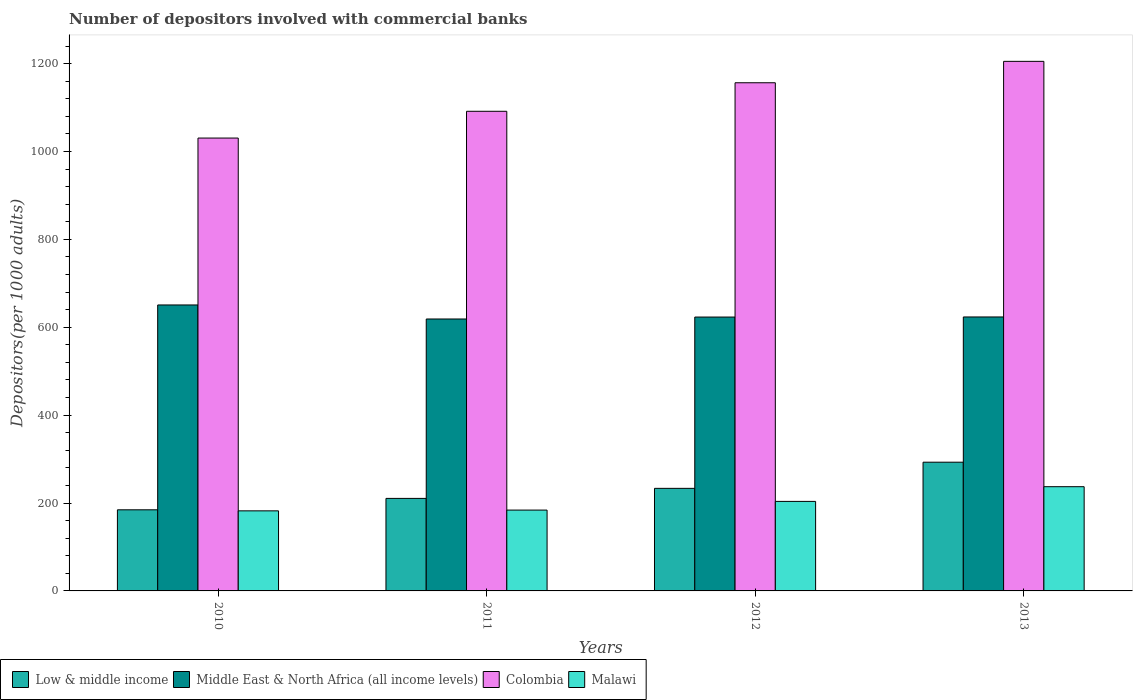How many different coloured bars are there?
Your answer should be compact. 4. How many groups of bars are there?
Provide a short and direct response. 4. What is the label of the 3rd group of bars from the left?
Your answer should be compact. 2012. In how many cases, is the number of bars for a given year not equal to the number of legend labels?
Provide a short and direct response. 0. What is the number of depositors involved with commercial banks in Low & middle income in 2012?
Provide a short and direct response. 233.41. Across all years, what is the maximum number of depositors involved with commercial banks in Low & middle income?
Offer a very short reply. 292.93. Across all years, what is the minimum number of depositors involved with commercial banks in Malawi?
Your answer should be compact. 182.23. In which year was the number of depositors involved with commercial banks in Middle East & North Africa (all income levels) minimum?
Offer a terse response. 2011. What is the total number of depositors involved with commercial banks in Malawi in the graph?
Offer a very short reply. 807.1. What is the difference between the number of depositors involved with commercial banks in Low & middle income in 2011 and that in 2013?
Offer a very short reply. -82.37. What is the difference between the number of depositors involved with commercial banks in Middle East & North Africa (all income levels) in 2010 and the number of depositors involved with commercial banks in Malawi in 2013?
Your answer should be very brief. 413.58. What is the average number of depositors involved with commercial banks in Malawi per year?
Offer a terse response. 201.78. In the year 2013, what is the difference between the number of depositors involved with commercial banks in Low & middle income and number of depositors involved with commercial banks in Malawi?
Your response must be concise. 55.74. What is the ratio of the number of depositors involved with commercial banks in Colombia in 2010 to that in 2011?
Give a very brief answer. 0.94. What is the difference between the highest and the second highest number of depositors involved with commercial banks in Malawi?
Keep it short and to the point. 33.47. What is the difference between the highest and the lowest number of depositors involved with commercial banks in Malawi?
Offer a terse response. 54.96. Is it the case that in every year, the sum of the number of depositors involved with commercial banks in Malawi and number of depositors involved with commercial banks in Low & middle income is greater than the sum of number of depositors involved with commercial banks in Middle East & North Africa (all income levels) and number of depositors involved with commercial banks in Colombia?
Ensure brevity in your answer.  No. What does the 4th bar from the left in 2010 represents?
Offer a very short reply. Malawi. What does the 3rd bar from the right in 2011 represents?
Provide a short and direct response. Middle East & North Africa (all income levels). Is it the case that in every year, the sum of the number of depositors involved with commercial banks in Low & middle income and number of depositors involved with commercial banks in Colombia is greater than the number of depositors involved with commercial banks in Malawi?
Ensure brevity in your answer.  Yes. How many bars are there?
Your response must be concise. 16. Are all the bars in the graph horizontal?
Keep it short and to the point. No. What is the difference between two consecutive major ticks on the Y-axis?
Your response must be concise. 200. Are the values on the major ticks of Y-axis written in scientific E-notation?
Offer a terse response. No. Does the graph contain grids?
Offer a very short reply. No. What is the title of the graph?
Ensure brevity in your answer.  Number of depositors involved with commercial banks. Does "Burundi" appear as one of the legend labels in the graph?
Offer a very short reply. No. What is the label or title of the Y-axis?
Make the answer very short. Depositors(per 1000 adults). What is the Depositors(per 1000 adults) of Low & middle income in 2010?
Offer a terse response. 184.58. What is the Depositors(per 1000 adults) in Middle East & North Africa (all income levels) in 2010?
Ensure brevity in your answer.  650.77. What is the Depositors(per 1000 adults) of Colombia in 2010?
Provide a succinct answer. 1030.59. What is the Depositors(per 1000 adults) of Malawi in 2010?
Offer a very short reply. 182.23. What is the Depositors(per 1000 adults) of Low & middle income in 2011?
Your answer should be compact. 210.56. What is the Depositors(per 1000 adults) of Middle East & North Africa (all income levels) in 2011?
Ensure brevity in your answer.  618.84. What is the Depositors(per 1000 adults) in Colombia in 2011?
Ensure brevity in your answer.  1091.5. What is the Depositors(per 1000 adults) in Malawi in 2011?
Provide a succinct answer. 183.96. What is the Depositors(per 1000 adults) in Low & middle income in 2012?
Give a very brief answer. 233.41. What is the Depositors(per 1000 adults) of Middle East & North Africa (all income levels) in 2012?
Keep it short and to the point. 623.22. What is the Depositors(per 1000 adults) of Colombia in 2012?
Your answer should be compact. 1156.43. What is the Depositors(per 1000 adults) in Malawi in 2012?
Give a very brief answer. 203.72. What is the Depositors(per 1000 adults) in Low & middle income in 2013?
Offer a very short reply. 292.93. What is the Depositors(per 1000 adults) of Middle East & North Africa (all income levels) in 2013?
Keep it short and to the point. 623.45. What is the Depositors(per 1000 adults) of Colombia in 2013?
Offer a terse response. 1205.13. What is the Depositors(per 1000 adults) of Malawi in 2013?
Provide a succinct answer. 237.19. Across all years, what is the maximum Depositors(per 1000 adults) in Low & middle income?
Your response must be concise. 292.93. Across all years, what is the maximum Depositors(per 1000 adults) of Middle East & North Africa (all income levels)?
Provide a succinct answer. 650.77. Across all years, what is the maximum Depositors(per 1000 adults) in Colombia?
Your answer should be compact. 1205.13. Across all years, what is the maximum Depositors(per 1000 adults) in Malawi?
Offer a terse response. 237.19. Across all years, what is the minimum Depositors(per 1000 adults) in Low & middle income?
Provide a short and direct response. 184.58. Across all years, what is the minimum Depositors(per 1000 adults) of Middle East & North Africa (all income levels)?
Offer a terse response. 618.84. Across all years, what is the minimum Depositors(per 1000 adults) in Colombia?
Your answer should be compact. 1030.59. Across all years, what is the minimum Depositors(per 1000 adults) in Malawi?
Provide a succinct answer. 182.23. What is the total Depositors(per 1000 adults) in Low & middle income in the graph?
Provide a short and direct response. 921.48. What is the total Depositors(per 1000 adults) in Middle East & North Africa (all income levels) in the graph?
Your answer should be very brief. 2516.28. What is the total Depositors(per 1000 adults) in Colombia in the graph?
Your response must be concise. 4483.65. What is the total Depositors(per 1000 adults) in Malawi in the graph?
Give a very brief answer. 807.1. What is the difference between the Depositors(per 1000 adults) of Low & middle income in 2010 and that in 2011?
Your answer should be compact. -25.98. What is the difference between the Depositors(per 1000 adults) in Middle East & North Africa (all income levels) in 2010 and that in 2011?
Your answer should be very brief. 31.92. What is the difference between the Depositors(per 1000 adults) in Colombia in 2010 and that in 2011?
Provide a short and direct response. -60.9. What is the difference between the Depositors(per 1000 adults) in Malawi in 2010 and that in 2011?
Your answer should be compact. -1.73. What is the difference between the Depositors(per 1000 adults) of Low & middle income in 2010 and that in 2012?
Keep it short and to the point. -48.83. What is the difference between the Depositors(per 1000 adults) in Middle East & North Africa (all income levels) in 2010 and that in 2012?
Give a very brief answer. 27.55. What is the difference between the Depositors(per 1000 adults) of Colombia in 2010 and that in 2012?
Offer a terse response. -125.84. What is the difference between the Depositors(per 1000 adults) of Malawi in 2010 and that in 2012?
Your answer should be very brief. -21.49. What is the difference between the Depositors(per 1000 adults) of Low & middle income in 2010 and that in 2013?
Your answer should be very brief. -108.35. What is the difference between the Depositors(per 1000 adults) in Middle East & North Africa (all income levels) in 2010 and that in 2013?
Give a very brief answer. 27.32. What is the difference between the Depositors(per 1000 adults) in Colombia in 2010 and that in 2013?
Keep it short and to the point. -174.54. What is the difference between the Depositors(per 1000 adults) of Malawi in 2010 and that in 2013?
Keep it short and to the point. -54.96. What is the difference between the Depositors(per 1000 adults) in Low & middle income in 2011 and that in 2012?
Provide a short and direct response. -22.85. What is the difference between the Depositors(per 1000 adults) of Middle East & North Africa (all income levels) in 2011 and that in 2012?
Keep it short and to the point. -4.38. What is the difference between the Depositors(per 1000 adults) of Colombia in 2011 and that in 2012?
Offer a very short reply. -64.94. What is the difference between the Depositors(per 1000 adults) of Malawi in 2011 and that in 2012?
Offer a very short reply. -19.76. What is the difference between the Depositors(per 1000 adults) of Low & middle income in 2011 and that in 2013?
Your answer should be compact. -82.37. What is the difference between the Depositors(per 1000 adults) in Middle East & North Africa (all income levels) in 2011 and that in 2013?
Provide a succinct answer. -4.61. What is the difference between the Depositors(per 1000 adults) in Colombia in 2011 and that in 2013?
Keep it short and to the point. -113.64. What is the difference between the Depositors(per 1000 adults) in Malawi in 2011 and that in 2013?
Give a very brief answer. -53.23. What is the difference between the Depositors(per 1000 adults) in Low & middle income in 2012 and that in 2013?
Provide a short and direct response. -59.52. What is the difference between the Depositors(per 1000 adults) of Middle East & North Africa (all income levels) in 2012 and that in 2013?
Keep it short and to the point. -0.23. What is the difference between the Depositors(per 1000 adults) in Colombia in 2012 and that in 2013?
Ensure brevity in your answer.  -48.7. What is the difference between the Depositors(per 1000 adults) in Malawi in 2012 and that in 2013?
Offer a very short reply. -33.47. What is the difference between the Depositors(per 1000 adults) of Low & middle income in 2010 and the Depositors(per 1000 adults) of Middle East & North Africa (all income levels) in 2011?
Give a very brief answer. -434.26. What is the difference between the Depositors(per 1000 adults) of Low & middle income in 2010 and the Depositors(per 1000 adults) of Colombia in 2011?
Offer a terse response. -906.92. What is the difference between the Depositors(per 1000 adults) in Low & middle income in 2010 and the Depositors(per 1000 adults) in Malawi in 2011?
Provide a succinct answer. 0.62. What is the difference between the Depositors(per 1000 adults) in Middle East & North Africa (all income levels) in 2010 and the Depositors(per 1000 adults) in Colombia in 2011?
Your answer should be very brief. -440.73. What is the difference between the Depositors(per 1000 adults) in Middle East & North Africa (all income levels) in 2010 and the Depositors(per 1000 adults) in Malawi in 2011?
Give a very brief answer. 466.81. What is the difference between the Depositors(per 1000 adults) of Colombia in 2010 and the Depositors(per 1000 adults) of Malawi in 2011?
Your answer should be very brief. 846.63. What is the difference between the Depositors(per 1000 adults) in Low & middle income in 2010 and the Depositors(per 1000 adults) in Middle East & North Africa (all income levels) in 2012?
Make the answer very short. -438.64. What is the difference between the Depositors(per 1000 adults) in Low & middle income in 2010 and the Depositors(per 1000 adults) in Colombia in 2012?
Your answer should be very brief. -971.85. What is the difference between the Depositors(per 1000 adults) in Low & middle income in 2010 and the Depositors(per 1000 adults) in Malawi in 2012?
Your response must be concise. -19.14. What is the difference between the Depositors(per 1000 adults) of Middle East & North Africa (all income levels) in 2010 and the Depositors(per 1000 adults) of Colombia in 2012?
Your response must be concise. -505.67. What is the difference between the Depositors(per 1000 adults) in Middle East & North Africa (all income levels) in 2010 and the Depositors(per 1000 adults) in Malawi in 2012?
Your response must be concise. 447.04. What is the difference between the Depositors(per 1000 adults) of Colombia in 2010 and the Depositors(per 1000 adults) of Malawi in 2012?
Your response must be concise. 826.87. What is the difference between the Depositors(per 1000 adults) in Low & middle income in 2010 and the Depositors(per 1000 adults) in Middle East & North Africa (all income levels) in 2013?
Provide a succinct answer. -438.87. What is the difference between the Depositors(per 1000 adults) in Low & middle income in 2010 and the Depositors(per 1000 adults) in Colombia in 2013?
Ensure brevity in your answer.  -1020.55. What is the difference between the Depositors(per 1000 adults) of Low & middle income in 2010 and the Depositors(per 1000 adults) of Malawi in 2013?
Provide a short and direct response. -52.61. What is the difference between the Depositors(per 1000 adults) in Middle East & North Africa (all income levels) in 2010 and the Depositors(per 1000 adults) in Colombia in 2013?
Your answer should be very brief. -554.37. What is the difference between the Depositors(per 1000 adults) of Middle East & North Africa (all income levels) in 2010 and the Depositors(per 1000 adults) of Malawi in 2013?
Your response must be concise. 413.58. What is the difference between the Depositors(per 1000 adults) of Colombia in 2010 and the Depositors(per 1000 adults) of Malawi in 2013?
Make the answer very short. 793.4. What is the difference between the Depositors(per 1000 adults) of Low & middle income in 2011 and the Depositors(per 1000 adults) of Middle East & North Africa (all income levels) in 2012?
Offer a very short reply. -412.66. What is the difference between the Depositors(per 1000 adults) in Low & middle income in 2011 and the Depositors(per 1000 adults) in Colombia in 2012?
Ensure brevity in your answer.  -945.87. What is the difference between the Depositors(per 1000 adults) in Low & middle income in 2011 and the Depositors(per 1000 adults) in Malawi in 2012?
Your answer should be very brief. 6.84. What is the difference between the Depositors(per 1000 adults) of Middle East & North Africa (all income levels) in 2011 and the Depositors(per 1000 adults) of Colombia in 2012?
Your answer should be very brief. -537.59. What is the difference between the Depositors(per 1000 adults) of Middle East & North Africa (all income levels) in 2011 and the Depositors(per 1000 adults) of Malawi in 2012?
Offer a terse response. 415.12. What is the difference between the Depositors(per 1000 adults) in Colombia in 2011 and the Depositors(per 1000 adults) in Malawi in 2012?
Your response must be concise. 887.77. What is the difference between the Depositors(per 1000 adults) of Low & middle income in 2011 and the Depositors(per 1000 adults) of Middle East & North Africa (all income levels) in 2013?
Ensure brevity in your answer.  -412.89. What is the difference between the Depositors(per 1000 adults) in Low & middle income in 2011 and the Depositors(per 1000 adults) in Colombia in 2013?
Offer a terse response. -994.57. What is the difference between the Depositors(per 1000 adults) in Low & middle income in 2011 and the Depositors(per 1000 adults) in Malawi in 2013?
Provide a short and direct response. -26.63. What is the difference between the Depositors(per 1000 adults) of Middle East & North Africa (all income levels) in 2011 and the Depositors(per 1000 adults) of Colombia in 2013?
Keep it short and to the point. -586.29. What is the difference between the Depositors(per 1000 adults) of Middle East & North Africa (all income levels) in 2011 and the Depositors(per 1000 adults) of Malawi in 2013?
Provide a succinct answer. 381.65. What is the difference between the Depositors(per 1000 adults) of Colombia in 2011 and the Depositors(per 1000 adults) of Malawi in 2013?
Your answer should be very brief. 854.31. What is the difference between the Depositors(per 1000 adults) of Low & middle income in 2012 and the Depositors(per 1000 adults) of Middle East & North Africa (all income levels) in 2013?
Offer a very short reply. -390.04. What is the difference between the Depositors(per 1000 adults) of Low & middle income in 2012 and the Depositors(per 1000 adults) of Colombia in 2013?
Offer a very short reply. -971.73. What is the difference between the Depositors(per 1000 adults) of Low & middle income in 2012 and the Depositors(per 1000 adults) of Malawi in 2013?
Give a very brief answer. -3.78. What is the difference between the Depositors(per 1000 adults) in Middle East & North Africa (all income levels) in 2012 and the Depositors(per 1000 adults) in Colombia in 2013?
Ensure brevity in your answer.  -581.91. What is the difference between the Depositors(per 1000 adults) in Middle East & North Africa (all income levels) in 2012 and the Depositors(per 1000 adults) in Malawi in 2013?
Provide a succinct answer. 386.03. What is the difference between the Depositors(per 1000 adults) in Colombia in 2012 and the Depositors(per 1000 adults) in Malawi in 2013?
Your answer should be very brief. 919.24. What is the average Depositors(per 1000 adults) in Low & middle income per year?
Offer a terse response. 230.37. What is the average Depositors(per 1000 adults) in Middle East & North Africa (all income levels) per year?
Ensure brevity in your answer.  629.07. What is the average Depositors(per 1000 adults) of Colombia per year?
Keep it short and to the point. 1120.91. What is the average Depositors(per 1000 adults) in Malawi per year?
Make the answer very short. 201.78. In the year 2010, what is the difference between the Depositors(per 1000 adults) in Low & middle income and Depositors(per 1000 adults) in Middle East & North Africa (all income levels)?
Your answer should be compact. -466.19. In the year 2010, what is the difference between the Depositors(per 1000 adults) of Low & middle income and Depositors(per 1000 adults) of Colombia?
Provide a short and direct response. -846.01. In the year 2010, what is the difference between the Depositors(per 1000 adults) in Low & middle income and Depositors(per 1000 adults) in Malawi?
Offer a terse response. 2.35. In the year 2010, what is the difference between the Depositors(per 1000 adults) of Middle East & North Africa (all income levels) and Depositors(per 1000 adults) of Colombia?
Provide a succinct answer. -379.82. In the year 2010, what is the difference between the Depositors(per 1000 adults) in Middle East & North Africa (all income levels) and Depositors(per 1000 adults) in Malawi?
Provide a succinct answer. 468.54. In the year 2010, what is the difference between the Depositors(per 1000 adults) of Colombia and Depositors(per 1000 adults) of Malawi?
Make the answer very short. 848.36. In the year 2011, what is the difference between the Depositors(per 1000 adults) of Low & middle income and Depositors(per 1000 adults) of Middle East & North Africa (all income levels)?
Provide a succinct answer. -408.28. In the year 2011, what is the difference between the Depositors(per 1000 adults) of Low & middle income and Depositors(per 1000 adults) of Colombia?
Provide a succinct answer. -880.93. In the year 2011, what is the difference between the Depositors(per 1000 adults) in Low & middle income and Depositors(per 1000 adults) in Malawi?
Your response must be concise. 26.6. In the year 2011, what is the difference between the Depositors(per 1000 adults) in Middle East & North Africa (all income levels) and Depositors(per 1000 adults) in Colombia?
Make the answer very short. -472.65. In the year 2011, what is the difference between the Depositors(per 1000 adults) in Middle East & North Africa (all income levels) and Depositors(per 1000 adults) in Malawi?
Keep it short and to the point. 434.88. In the year 2011, what is the difference between the Depositors(per 1000 adults) of Colombia and Depositors(per 1000 adults) of Malawi?
Give a very brief answer. 907.54. In the year 2012, what is the difference between the Depositors(per 1000 adults) of Low & middle income and Depositors(per 1000 adults) of Middle East & North Africa (all income levels)?
Provide a short and direct response. -389.81. In the year 2012, what is the difference between the Depositors(per 1000 adults) of Low & middle income and Depositors(per 1000 adults) of Colombia?
Offer a terse response. -923.03. In the year 2012, what is the difference between the Depositors(per 1000 adults) in Low & middle income and Depositors(per 1000 adults) in Malawi?
Ensure brevity in your answer.  29.68. In the year 2012, what is the difference between the Depositors(per 1000 adults) in Middle East & North Africa (all income levels) and Depositors(per 1000 adults) in Colombia?
Provide a short and direct response. -533.21. In the year 2012, what is the difference between the Depositors(per 1000 adults) of Middle East & North Africa (all income levels) and Depositors(per 1000 adults) of Malawi?
Give a very brief answer. 419.5. In the year 2012, what is the difference between the Depositors(per 1000 adults) of Colombia and Depositors(per 1000 adults) of Malawi?
Offer a terse response. 952.71. In the year 2013, what is the difference between the Depositors(per 1000 adults) of Low & middle income and Depositors(per 1000 adults) of Middle East & North Africa (all income levels)?
Keep it short and to the point. -330.52. In the year 2013, what is the difference between the Depositors(per 1000 adults) in Low & middle income and Depositors(per 1000 adults) in Colombia?
Offer a terse response. -912.2. In the year 2013, what is the difference between the Depositors(per 1000 adults) in Low & middle income and Depositors(per 1000 adults) in Malawi?
Keep it short and to the point. 55.74. In the year 2013, what is the difference between the Depositors(per 1000 adults) in Middle East & North Africa (all income levels) and Depositors(per 1000 adults) in Colombia?
Provide a succinct answer. -581.69. In the year 2013, what is the difference between the Depositors(per 1000 adults) in Middle East & North Africa (all income levels) and Depositors(per 1000 adults) in Malawi?
Your answer should be compact. 386.26. In the year 2013, what is the difference between the Depositors(per 1000 adults) of Colombia and Depositors(per 1000 adults) of Malawi?
Your answer should be very brief. 967.94. What is the ratio of the Depositors(per 1000 adults) of Low & middle income in 2010 to that in 2011?
Your response must be concise. 0.88. What is the ratio of the Depositors(per 1000 adults) of Middle East & North Africa (all income levels) in 2010 to that in 2011?
Make the answer very short. 1.05. What is the ratio of the Depositors(per 1000 adults) of Colombia in 2010 to that in 2011?
Give a very brief answer. 0.94. What is the ratio of the Depositors(per 1000 adults) in Malawi in 2010 to that in 2011?
Offer a very short reply. 0.99. What is the ratio of the Depositors(per 1000 adults) of Low & middle income in 2010 to that in 2012?
Your response must be concise. 0.79. What is the ratio of the Depositors(per 1000 adults) in Middle East & North Africa (all income levels) in 2010 to that in 2012?
Your answer should be compact. 1.04. What is the ratio of the Depositors(per 1000 adults) of Colombia in 2010 to that in 2012?
Keep it short and to the point. 0.89. What is the ratio of the Depositors(per 1000 adults) of Malawi in 2010 to that in 2012?
Offer a terse response. 0.89. What is the ratio of the Depositors(per 1000 adults) in Low & middle income in 2010 to that in 2013?
Ensure brevity in your answer.  0.63. What is the ratio of the Depositors(per 1000 adults) of Middle East & North Africa (all income levels) in 2010 to that in 2013?
Ensure brevity in your answer.  1.04. What is the ratio of the Depositors(per 1000 adults) of Colombia in 2010 to that in 2013?
Offer a terse response. 0.86. What is the ratio of the Depositors(per 1000 adults) of Malawi in 2010 to that in 2013?
Offer a very short reply. 0.77. What is the ratio of the Depositors(per 1000 adults) in Low & middle income in 2011 to that in 2012?
Ensure brevity in your answer.  0.9. What is the ratio of the Depositors(per 1000 adults) in Colombia in 2011 to that in 2012?
Offer a very short reply. 0.94. What is the ratio of the Depositors(per 1000 adults) in Malawi in 2011 to that in 2012?
Ensure brevity in your answer.  0.9. What is the ratio of the Depositors(per 1000 adults) of Low & middle income in 2011 to that in 2013?
Make the answer very short. 0.72. What is the ratio of the Depositors(per 1000 adults) of Middle East & North Africa (all income levels) in 2011 to that in 2013?
Offer a terse response. 0.99. What is the ratio of the Depositors(per 1000 adults) in Colombia in 2011 to that in 2013?
Offer a very short reply. 0.91. What is the ratio of the Depositors(per 1000 adults) of Malawi in 2011 to that in 2013?
Provide a succinct answer. 0.78. What is the ratio of the Depositors(per 1000 adults) in Low & middle income in 2012 to that in 2013?
Offer a terse response. 0.8. What is the ratio of the Depositors(per 1000 adults) in Middle East & North Africa (all income levels) in 2012 to that in 2013?
Your answer should be very brief. 1. What is the ratio of the Depositors(per 1000 adults) in Colombia in 2012 to that in 2013?
Your answer should be compact. 0.96. What is the ratio of the Depositors(per 1000 adults) of Malawi in 2012 to that in 2013?
Offer a very short reply. 0.86. What is the difference between the highest and the second highest Depositors(per 1000 adults) of Low & middle income?
Keep it short and to the point. 59.52. What is the difference between the highest and the second highest Depositors(per 1000 adults) in Middle East & North Africa (all income levels)?
Provide a succinct answer. 27.32. What is the difference between the highest and the second highest Depositors(per 1000 adults) in Colombia?
Your response must be concise. 48.7. What is the difference between the highest and the second highest Depositors(per 1000 adults) of Malawi?
Offer a very short reply. 33.47. What is the difference between the highest and the lowest Depositors(per 1000 adults) of Low & middle income?
Give a very brief answer. 108.35. What is the difference between the highest and the lowest Depositors(per 1000 adults) in Middle East & North Africa (all income levels)?
Your answer should be compact. 31.92. What is the difference between the highest and the lowest Depositors(per 1000 adults) of Colombia?
Provide a succinct answer. 174.54. What is the difference between the highest and the lowest Depositors(per 1000 adults) in Malawi?
Provide a short and direct response. 54.96. 